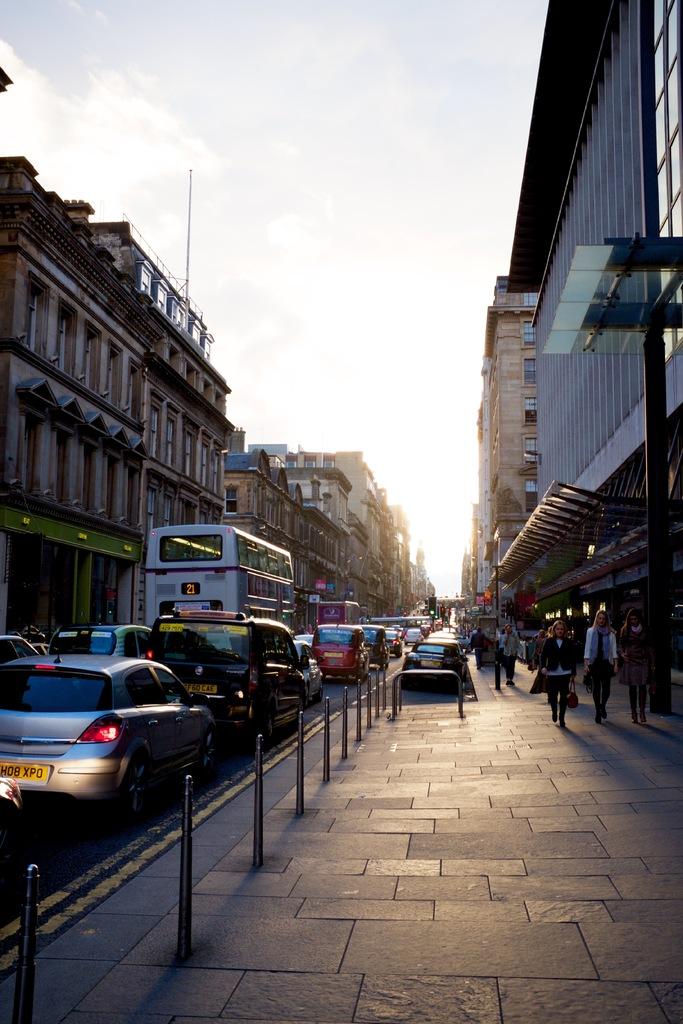What number is the bus route?
Offer a very short reply. 21. 